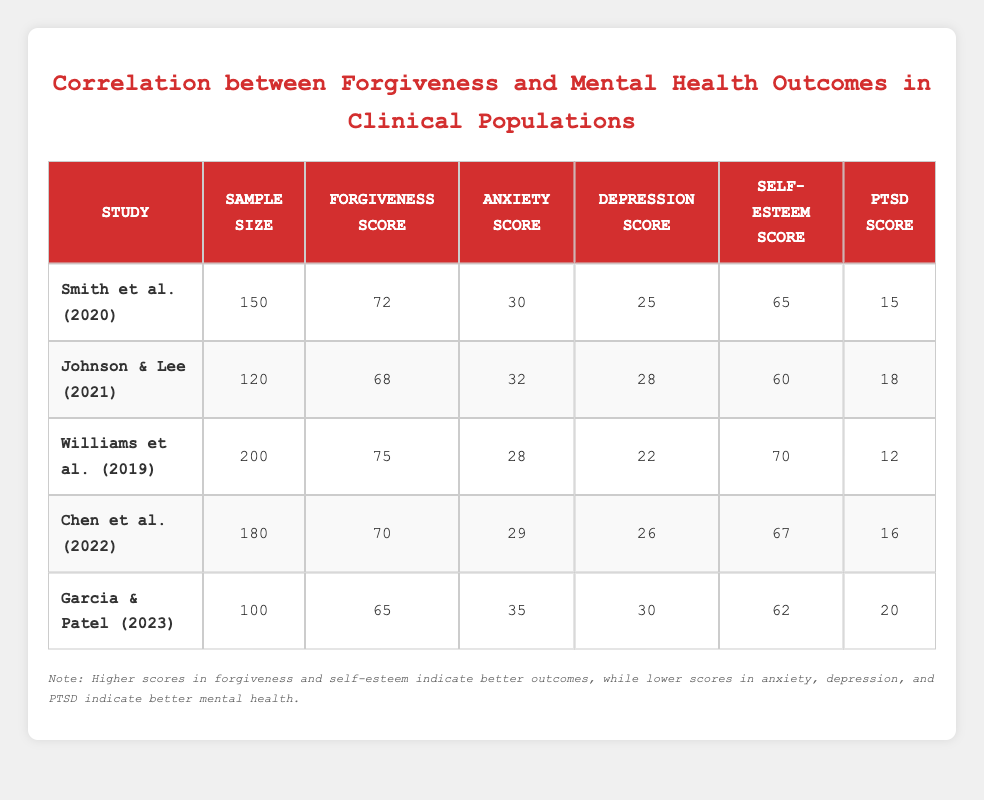What is the forgiveness score for Williams et al. (2019)? The forgiveness score for Williams et al. (2019) can be found directly in the table. It is listed in the "Forgiveness Score" column for the study.
Answer: 75 What is the sample size of the study conducted by Johnson & Lee (2021)? The sample size for Johnson & Lee (2021) is provided in the "Sample Size" column next to the study name in the table.
Answer: 120 Which study has the lowest PTSD score? To determine the study with the lowest PTSD score, we need to compare all the values in the "PTSD Score" column. The scores are 15, 18, 12, 16, and 20. Williams et al. (2019) has the lowest score of 12.
Answer: Williams et al. (2019) What is the average anxiety score across all studies? To find the average anxiety score, first sum the anxiety scores: 30 + 32 + 28 + 29 + 35 = 154. Then, divide by the number of studies (5): 154/5 = 30.8.
Answer: 30.8 Is there a study with a self-esteem score higher than 70? Check the "Self-esteem Score" column for all studies. The scores are 65, 60, 70, 67, and 62. None of the studies have a self-esteem score higher than 70.
Answer: No Which two studies have forgiveness scores greater than 70? Look at the "Forgiveness Score" column and identify the studies with scores above 70: Smith et al. (2020) with 72 and Williams et al. (2019) with 75. These are the two studies that meet the criteria.
Answer: Smith et al. (2020), Williams et al. (2019) What is the difference between the highest and lowest depression scores recorded in the studies? Locate the highest and lowest depression scores in the "Depression Score" column. The highest is 30 (Garcia & Patel, 2023) and the lowest is 22 (Williams et al., 2019). The difference is 30 - 22 = 8.
Answer: 8 Which studies show a positive correlation between forgiveness scores and self-esteem scores? To evaluate which studies show a positive correlation, compare the "Forgiveness Score" and "Self-esteem Score" columns. Both Smith et al. (2020) and Williams et al. (2019) show higher forgiveness scores correlating with higher self-esteem scores (72 & 65, and 75 & 70 respectively).
Answer: Smith et al. (2020), Williams et al. (2019) 